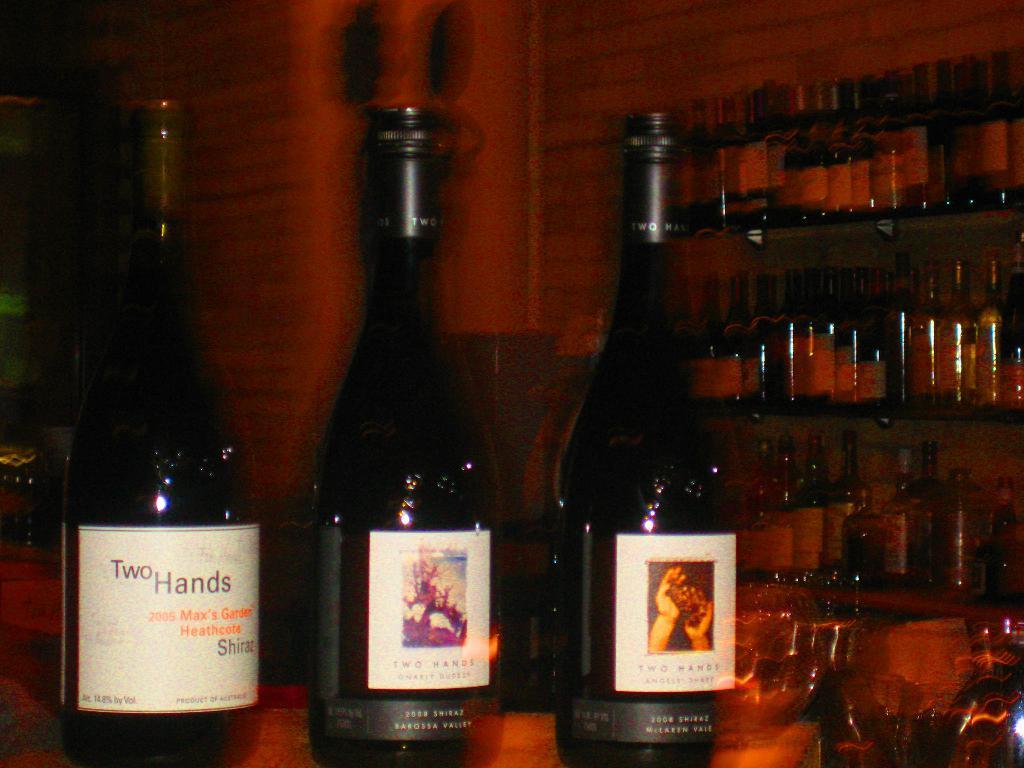Can you describe this image briefly? In this image we can see bottles on the table and few bottles on the shelf and a wall in the background. 